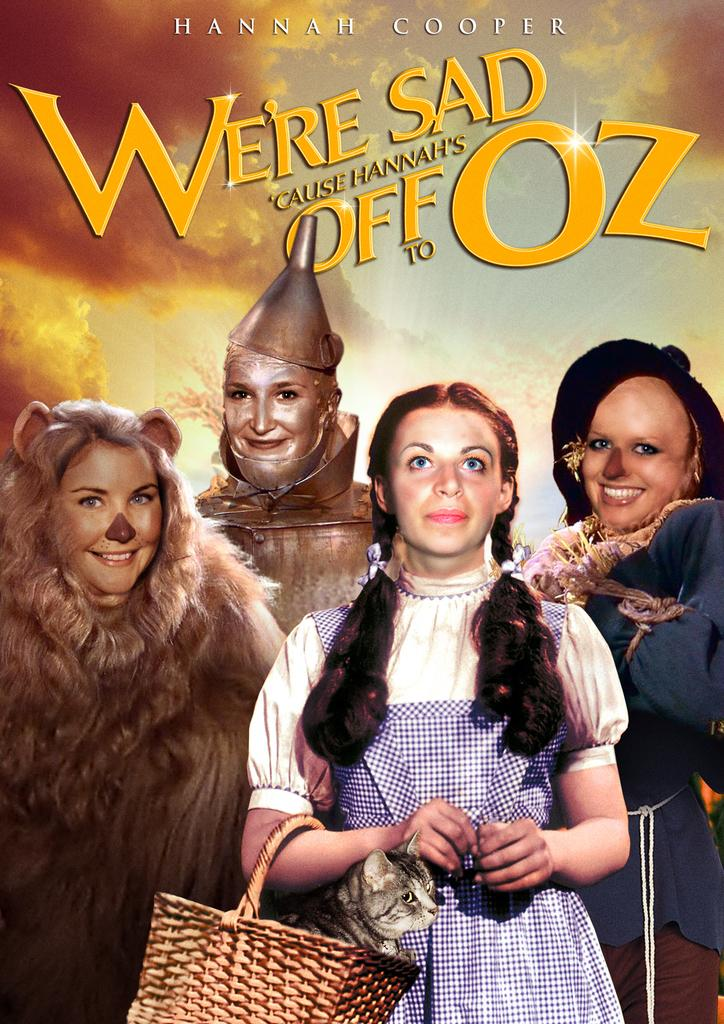What is present in the image? There is a poster in the image. How many crows are perched on the hydrant in the image? There is no hydrant or crow present in the image; only the poster is visible. 